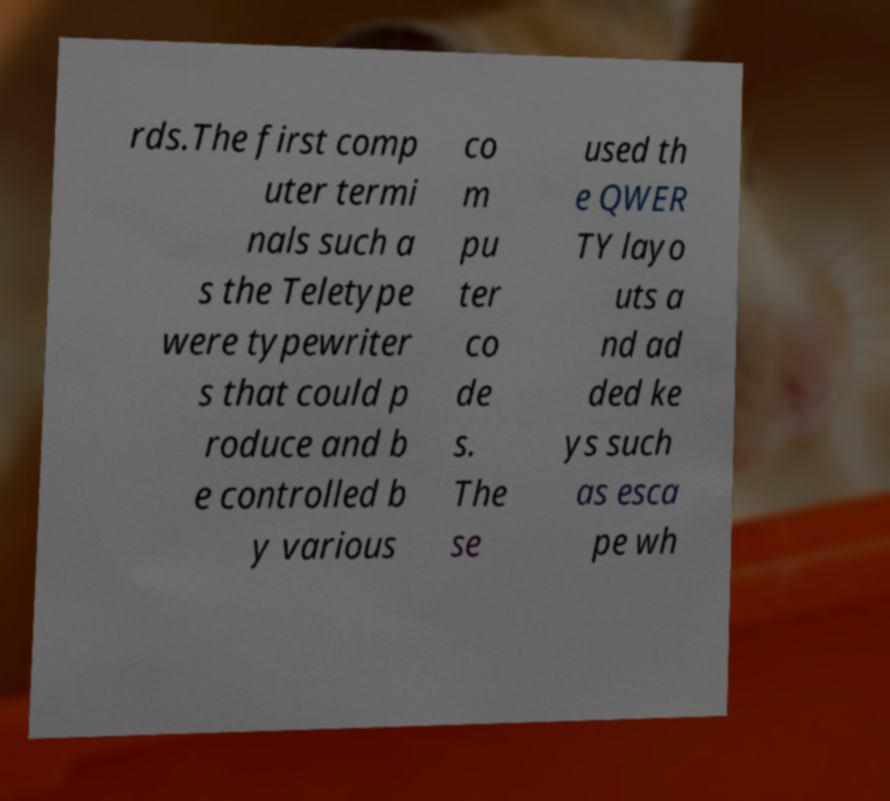There's text embedded in this image that I need extracted. Can you transcribe it verbatim? rds.The first comp uter termi nals such a s the Teletype were typewriter s that could p roduce and b e controlled b y various co m pu ter co de s. The se used th e QWER TY layo uts a nd ad ded ke ys such as esca pe wh 